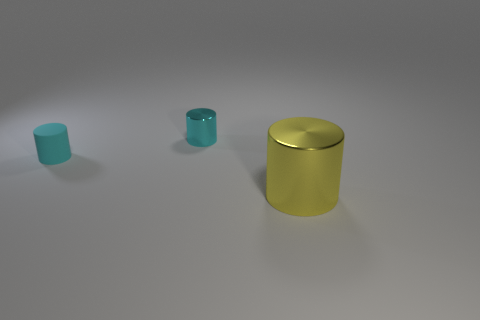Subtract all cyan cubes. How many cyan cylinders are left? 2 Subtract all rubber cylinders. How many cylinders are left? 2 Add 1 large cylinders. How many objects exist? 4 Subtract 1 cylinders. How many cylinders are left? 2 Subtract all green cylinders. Subtract all brown balls. How many cylinders are left? 3 Add 3 small cyan rubber things. How many small cyan rubber things exist? 4 Subtract 1 yellow cylinders. How many objects are left? 2 Subtract all small metallic cylinders. Subtract all matte objects. How many objects are left? 1 Add 1 cyan things. How many cyan things are left? 3 